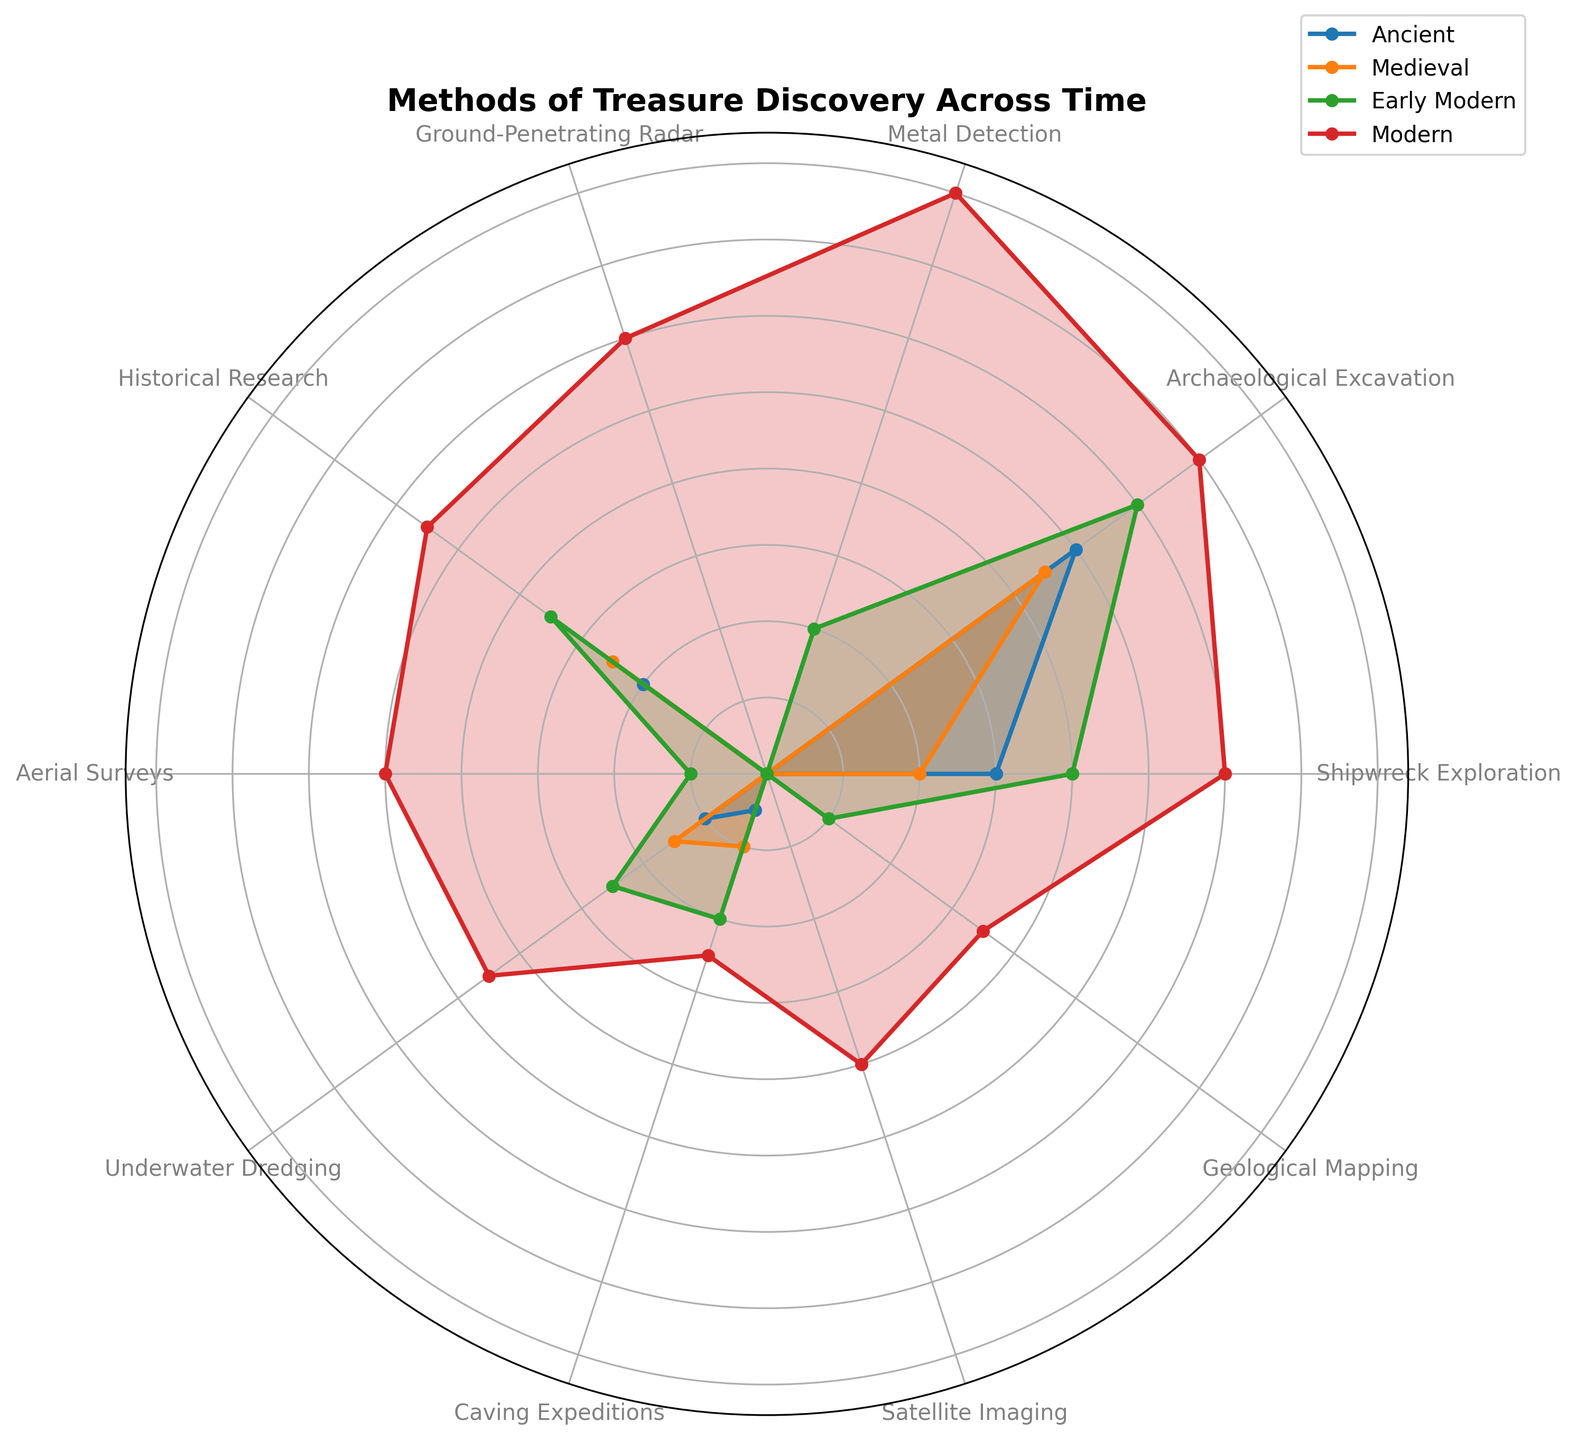Which method of treasure discovery has seen the greatest increase from the Ancient to Modern periods? By observing the length of the lines for each method between the Ancient and Modern periods, we can see that Metal Detection increased from 0 to 80, a significant rise compared to other methods.
Answer: Metal Detection What's the average percentage of treasure discoveries using Historical Research across all periods? The values for Historical Research are: 20, 25, 35, and 55. Adding these gives 135. Dividing by the 4 periods, we get an average of 33.75.
Answer: 33.75 Which period shows the most diverse range of methods used for treasure discovery? Examining the spread of points in each period's line, the Modern period shows the widest distribution of methods used, as methods have greater variability in values.
Answer: Modern By how much did the use of Archaeological Excavation increase from the Medieval to the Modern period? The values are 45 in the Medieval period and 70 in the Modern period. The increase is 70 - 45 = 25.
Answer: 25 Which method was not used at all in the Ancient and Medieval periods but became relevant in the Early Modern period? Looking at the line plots, Metal Detection started from zero in Ancient and Medieval periods and appeared in the Early Modern period with a value of 20.
Answer: Metal Detection Which period had the highest percentage of Shipwreck Exploration? By comparing the lengths of the lines for Shipwreck Exploration across periods, the Modern period has the highest value at 60.
Answer: Modern How do the proportions of Caving Expeditions change from Ancient to Early Modern to Modern periods? The values are 5, 10, 20, and 25 for Ancient, Medieval, Early Modern, and Modern periods, respectively, showing a steady increase.
Answer: Increase steadily What is the total percentage of treasure discoveries using Ground-Penetrating Radar across all periods? Summing the values for Ground-Penetrating Radar, which only appear in the Modern period, gives 60.
Answer: 60 Which method showed the fastest adoption in the Modern period, appearing for the first time? The methods that show zero before appearing in the Modern period include Ground-Penetrating Radar and Satellite Imaging. Both show an initial jump to higher values.
Answer: Ground-Penetrating Radar and Satellite Imaging Compare the use of Aerial Surveys in the Early Modern period to the Modern period. The value for Aerial Surveys in the Early Modern period is 10 compared to 50 in the Modern period, indicating a rise of 40 units.
Answer: Increased by 40 